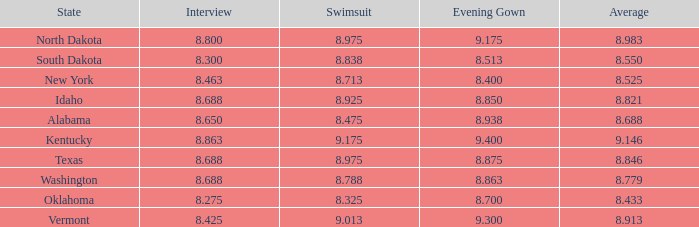What is the highest average of the contestant from Texas with an evening gown larger than 8.875? None. 